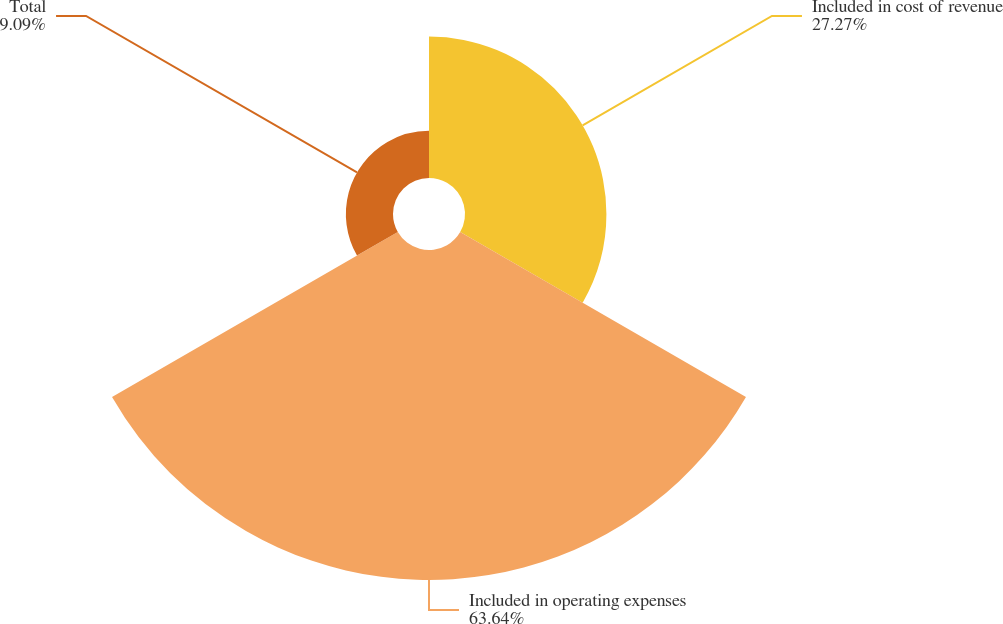Convert chart to OTSL. <chart><loc_0><loc_0><loc_500><loc_500><pie_chart><fcel>Included in cost of revenue<fcel>Included in operating expenses<fcel>Total<nl><fcel>27.27%<fcel>63.64%<fcel>9.09%<nl></chart> 